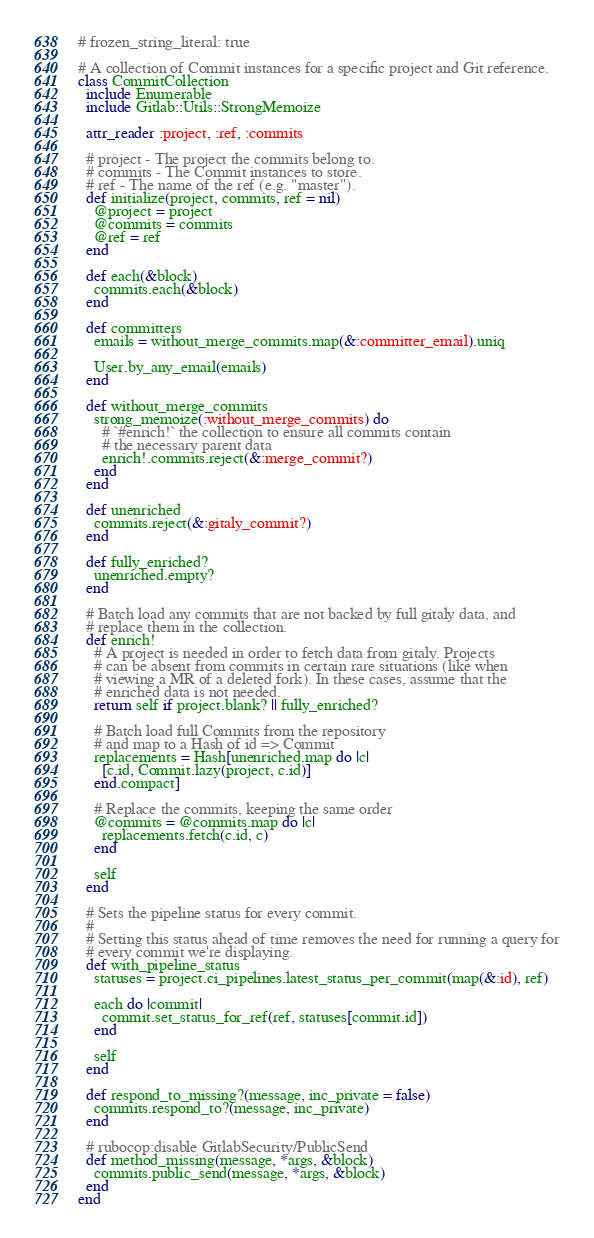<code> <loc_0><loc_0><loc_500><loc_500><_Ruby_># frozen_string_literal: true

# A collection of Commit instances for a specific project and Git reference.
class CommitCollection
  include Enumerable
  include Gitlab::Utils::StrongMemoize

  attr_reader :project, :ref, :commits

  # project - The project the commits belong to.
  # commits - The Commit instances to store.
  # ref - The name of the ref (e.g. "master").
  def initialize(project, commits, ref = nil)
    @project = project
    @commits = commits
    @ref = ref
  end

  def each(&block)
    commits.each(&block)
  end

  def committers
    emails = without_merge_commits.map(&:committer_email).uniq

    User.by_any_email(emails)
  end

  def without_merge_commits
    strong_memoize(:without_merge_commits) do
      # `#enrich!` the collection to ensure all commits contain
      # the necessary parent data
      enrich!.commits.reject(&:merge_commit?)
    end
  end

  def unenriched
    commits.reject(&:gitaly_commit?)
  end

  def fully_enriched?
    unenriched.empty?
  end

  # Batch load any commits that are not backed by full gitaly data, and
  # replace them in the collection.
  def enrich!
    # A project is needed in order to fetch data from gitaly. Projects
    # can be absent from commits in certain rare situations (like when
    # viewing a MR of a deleted fork). In these cases, assume that the
    # enriched data is not needed.
    return self if project.blank? || fully_enriched?

    # Batch load full Commits from the repository
    # and map to a Hash of id => Commit
    replacements = Hash[unenriched.map do |c|
      [c.id, Commit.lazy(project, c.id)]
    end.compact]

    # Replace the commits, keeping the same order
    @commits = @commits.map do |c|
      replacements.fetch(c.id, c)
    end

    self
  end

  # Sets the pipeline status for every commit.
  #
  # Setting this status ahead of time removes the need for running a query for
  # every commit we're displaying.
  def with_pipeline_status
    statuses = project.ci_pipelines.latest_status_per_commit(map(&:id), ref)

    each do |commit|
      commit.set_status_for_ref(ref, statuses[commit.id])
    end

    self
  end

  def respond_to_missing?(message, inc_private = false)
    commits.respond_to?(message, inc_private)
  end

  # rubocop:disable GitlabSecurity/PublicSend
  def method_missing(message, *args, &block)
    commits.public_send(message, *args, &block)
  end
end
</code> 